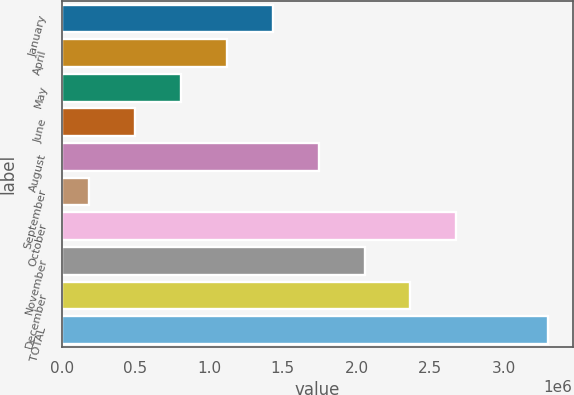Convert chart to OTSL. <chart><loc_0><loc_0><loc_500><loc_500><bar_chart><fcel>January<fcel>April<fcel>May<fcel>June<fcel>August<fcel>September<fcel>October<fcel>November<fcel>December<fcel>TOTAL<nl><fcel>1.431e+06<fcel>1.11975e+06<fcel>808498<fcel>497249<fcel>1.74224e+06<fcel>186000<fcel>2.67599e+06<fcel>2.05349e+06<fcel>2.36474e+06<fcel>3.29849e+06<nl></chart> 